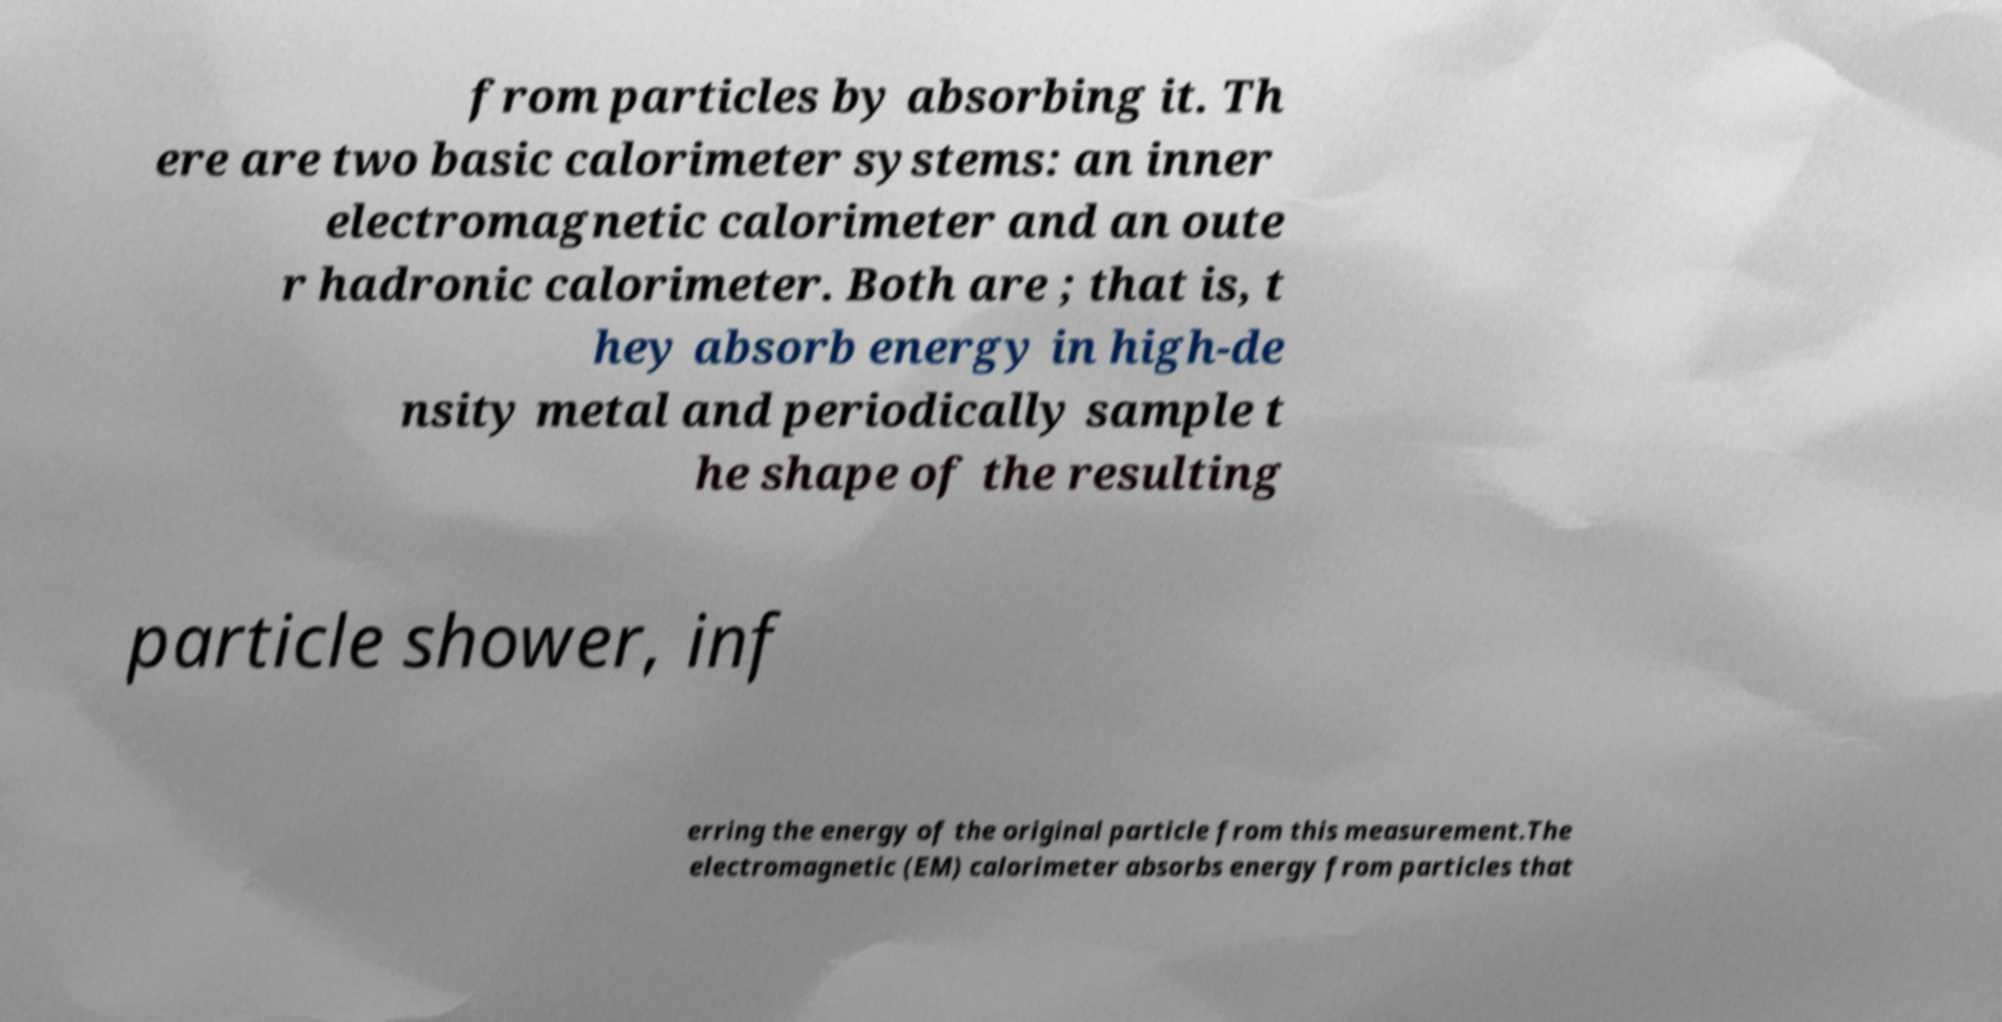For documentation purposes, I need the text within this image transcribed. Could you provide that? from particles by absorbing it. Th ere are two basic calorimeter systems: an inner electromagnetic calorimeter and an oute r hadronic calorimeter. Both are ; that is, t hey absorb energy in high-de nsity metal and periodically sample t he shape of the resulting particle shower, inf erring the energy of the original particle from this measurement.The electromagnetic (EM) calorimeter absorbs energy from particles that 